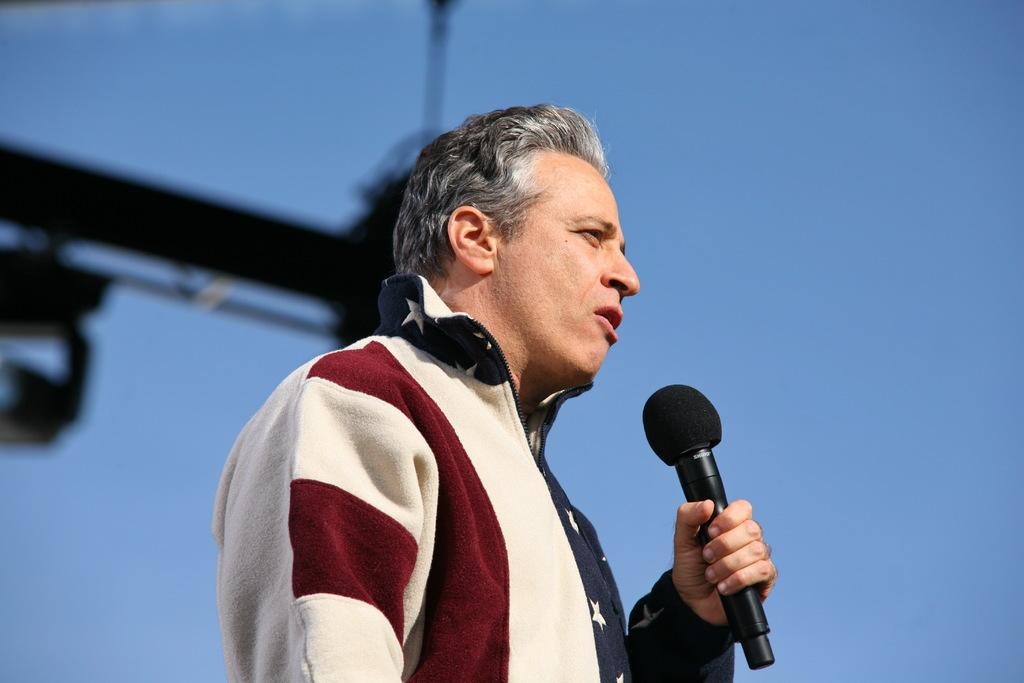Who is the main subject in the image? There is a man in the image. What is the man doing in the image? The man is talking on a microphone. What type of frog can be seen sitting on the man's shoulder in the image? There is no frog present in the image; the man is talking on a microphone. 